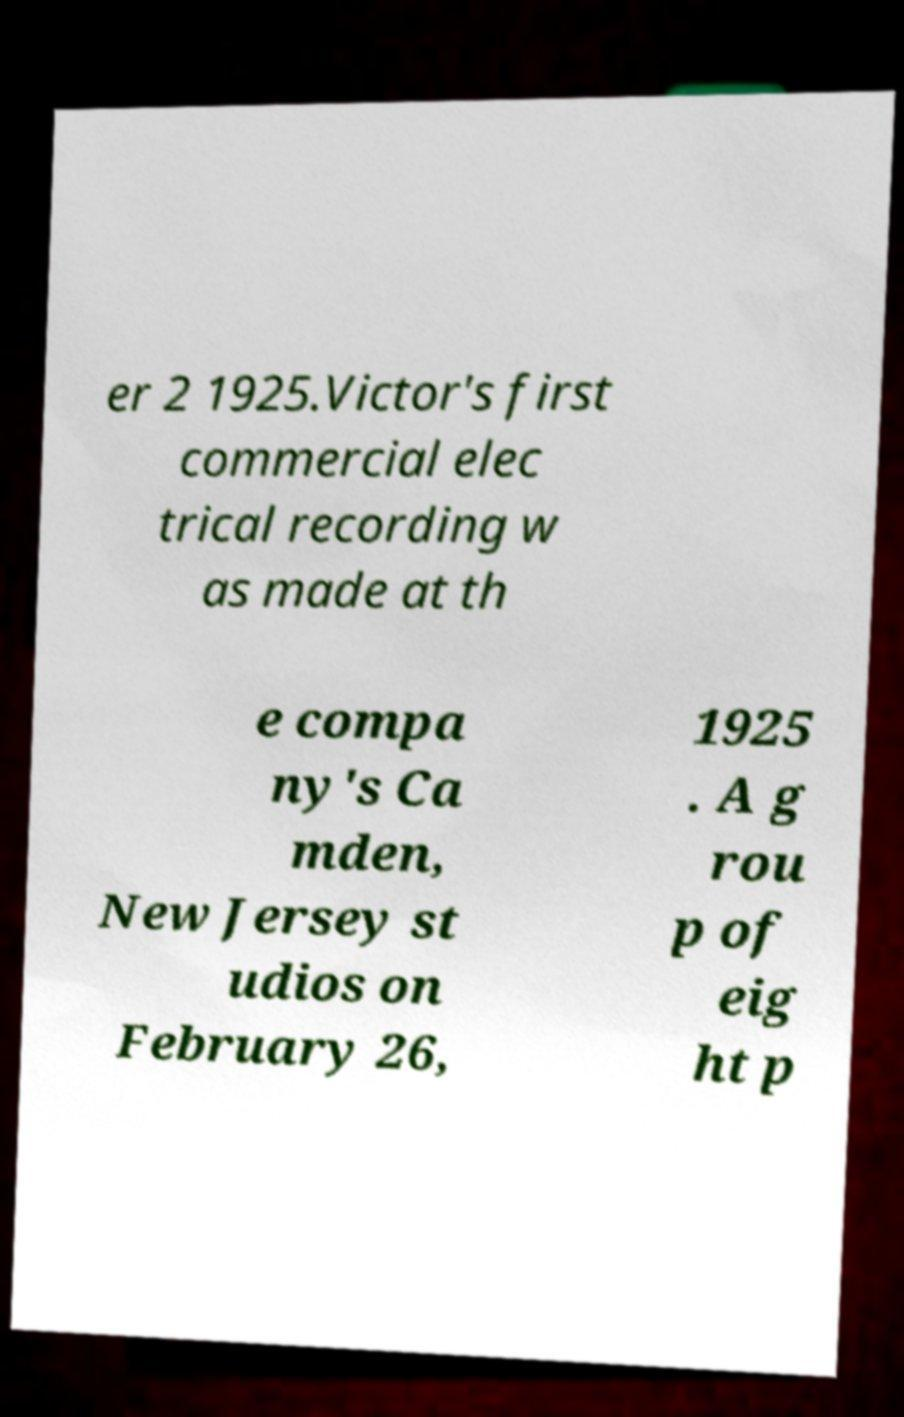Please read and relay the text visible in this image. What does it say? er 2 1925.Victor's first commercial elec trical recording w as made at th e compa ny's Ca mden, New Jersey st udios on February 26, 1925 . A g rou p of eig ht p 